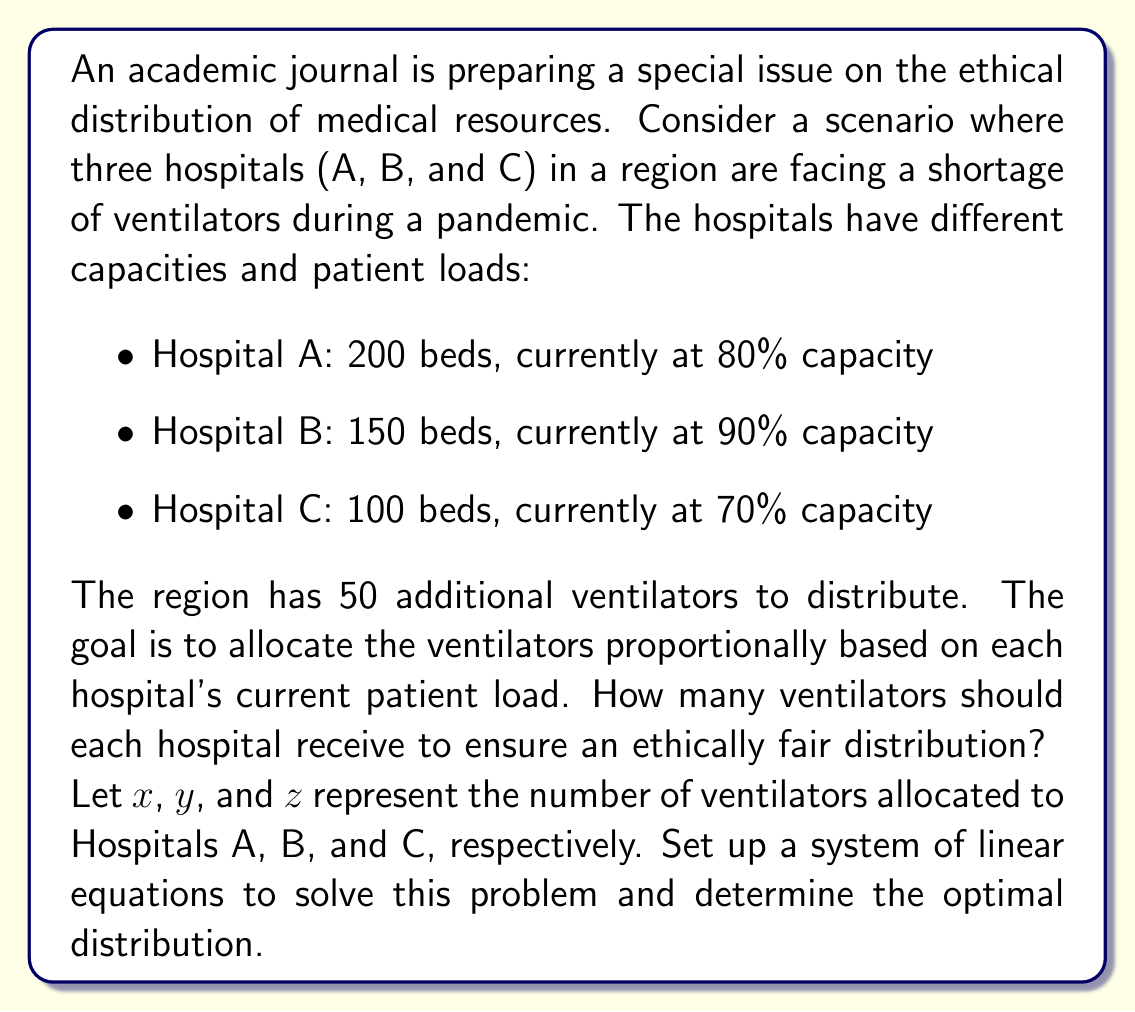Help me with this question. To solve this problem, we need to follow these steps:

1. Calculate the current patient load for each hospital:
   Hospital A: $200 \times 0.80 = 160$ patients
   Hospital B: $150 \times 0.90 = 135$ patients
   Hospital C: $100 \times 0.70 = 70$ patients

2. Calculate the total patient load: $160 + 135 + 70 = 365$ patients

3. Set up a system of linear equations based on the proportional distribution:

   $$\frac{x}{160} = \frac{y}{135} = \frac{z}{70} = \frac{50}{365}$$

4. Simplify the equations:
   $$\frac{x}{160} = \frac{50}{365}$$
   $$\frac{y}{135} = \frac{50}{365}$$
   $$\frac{z}{70} = \frac{50}{365}$$

5. Solve for $x$, $y$, and $z$:

   $$x = \frac{160 \times 50}{365} \approx 21.92$$
   $$y = \frac{135 \times 50}{365} \approx 18.49$$
   $$z = \frac{70 \times 50}{365} \approx 9.59$$

6. Since we can't allocate fractional ventilators, we need to round these values to the nearest whole number while ensuring the total remains 50:

   Hospital A: 22 ventilators
   Hospital B: 18 ventilators
   Hospital C: 10 ventilators

   Total: $22 + 18 + 10 = 50$ ventilators

This distribution ensures that each hospital receives a number of ventilators proportional to its current patient load, providing an ethically fair allocation of the limited medical resources.
Answer: Hospital A should receive 22 ventilators, Hospital B should receive 18 ventilators, and Hospital C should receive 10 ventilators. 